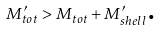Convert formula to latex. <formula><loc_0><loc_0><loc_500><loc_500>M _ { t o t } ^ { \prime } > M _ { t o t } + M _ { s h e l l } ^ { \prime } \text {.}</formula> 